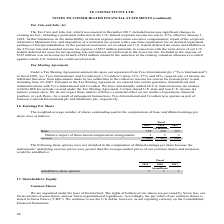From Te Connectivity's financial document, In which years was the basic earnings per share calculated for? The document contains multiple relevant values: 2019, 2018, 2017. From the document: "2019 2018 2017 2019 2018 2017 2019 2018 2017..." Also, What was used in the computations of basic and diluted earnings per share? The weighted-average number of shares outstanding. The document states: "The weighted-average number of shares outstanding used in the computations of basic and diluted earnings per..." Also, What are the types of earnings per share analyzed in the table? The document shows two values: Basic and Diluted. From the document: "Diluted 340 353 358 Basic 338 350 355..." Additionally, Which year was the basic earnings per share the largest? According to the financial document, 2017. The relevant text states: "2019 2018 2017..." Also, can you calculate: What was the change in Dilutive impact of share-based compensation arrangements in 2019 from 2018? Based on the calculation: 2-3, the result is -1 (in millions). This is based on the information: "e impact of share-based compensation arrangements 2 3 3 impact of share-based compensation arrangements 2 3 3..." The key data points involved are: 2, 3. Also, can you calculate: What was the percentage change in Dilutive impact of share-based compensation arrangements in 2019 from 2018? To answer this question, I need to perform calculations using the financial data. The calculation is: (2-3)/3, which equals -33.33 (percentage). This is based on the information: "e impact of share-based compensation arrangements 2 3 3 impact of share-based compensation arrangements 2 3 3..." The key data points involved are: 2. 